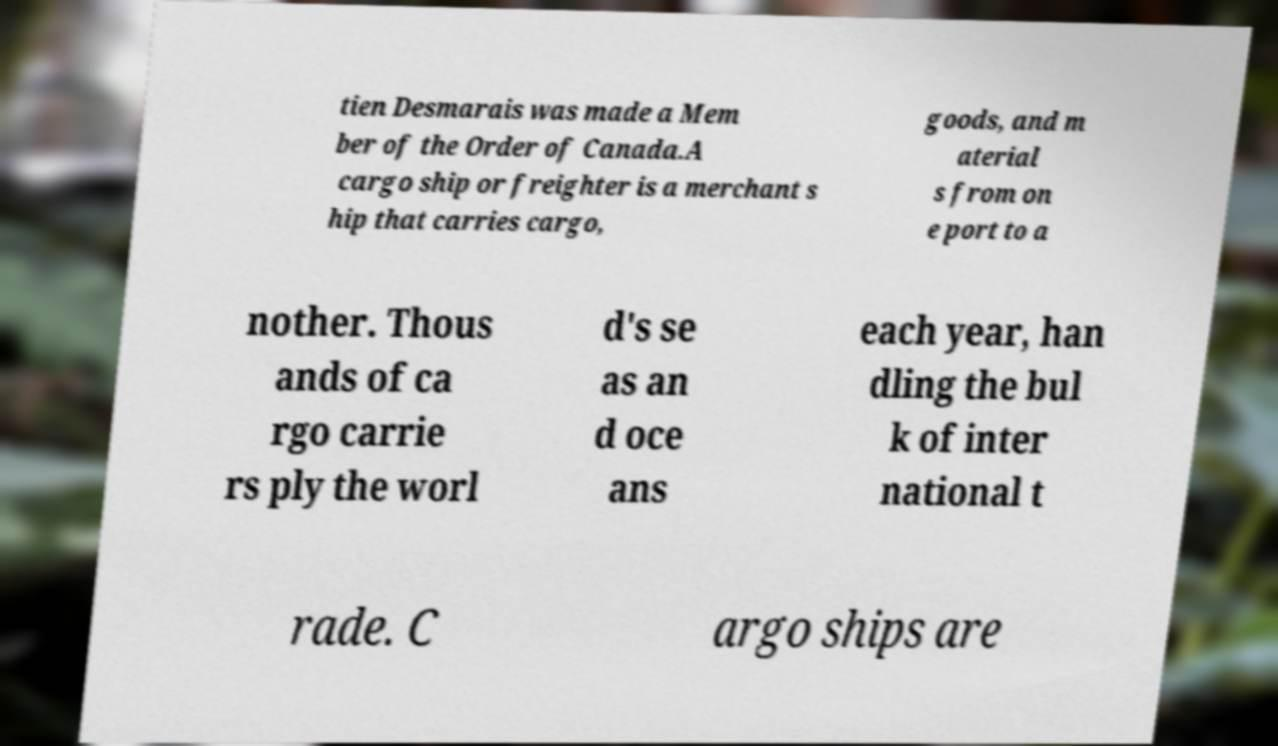Please identify and transcribe the text found in this image. tien Desmarais was made a Mem ber of the Order of Canada.A cargo ship or freighter is a merchant s hip that carries cargo, goods, and m aterial s from on e port to a nother. Thous ands of ca rgo carrie rs ply the worl d's se as an d oce ans each year, han dling the bul k of inter national t rade. C argo ships are 